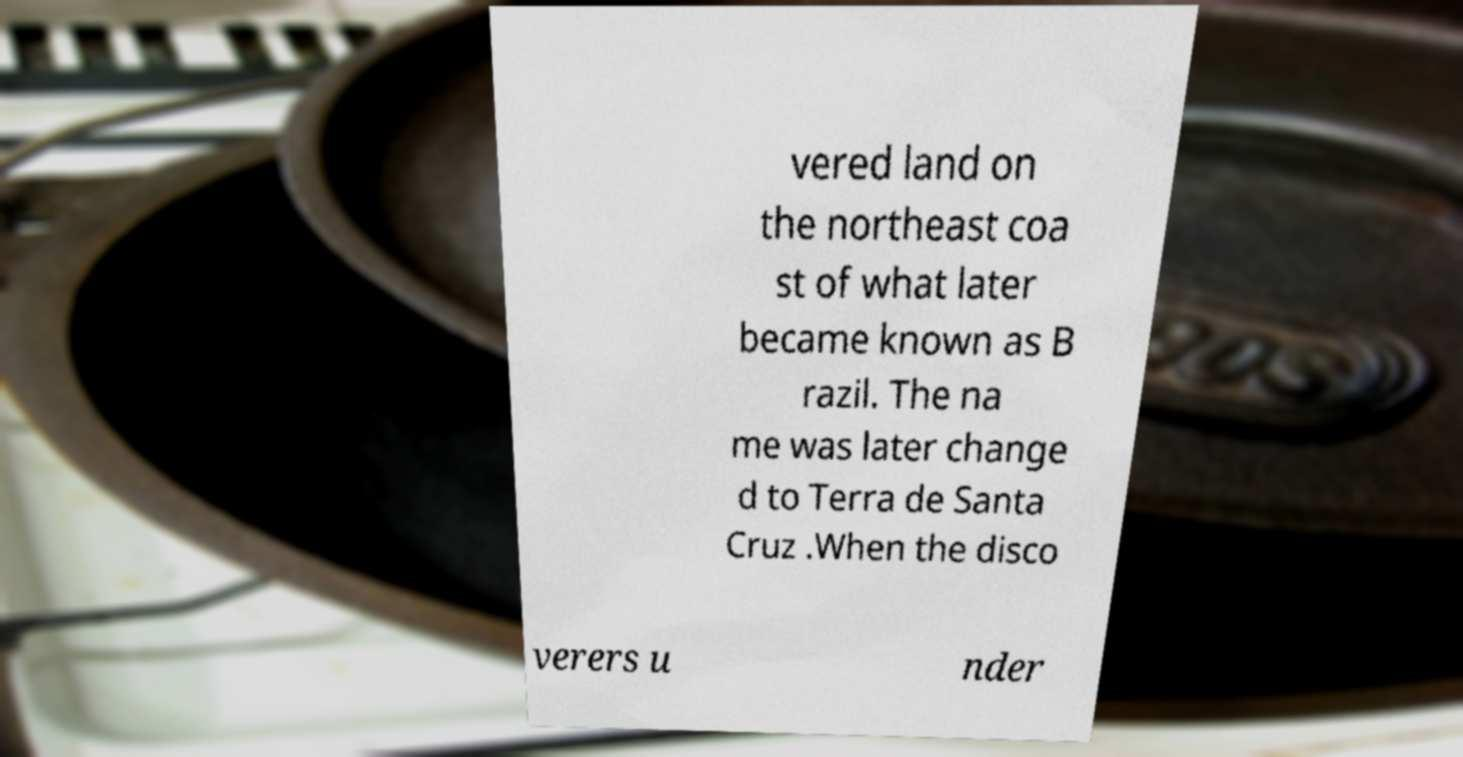Please identify and transcribe the text found in this image. vered land on the northeast coa st of what later became known as B razil. The na me was later change d to Terra de Santa Cruz .When the disco verers u nder 